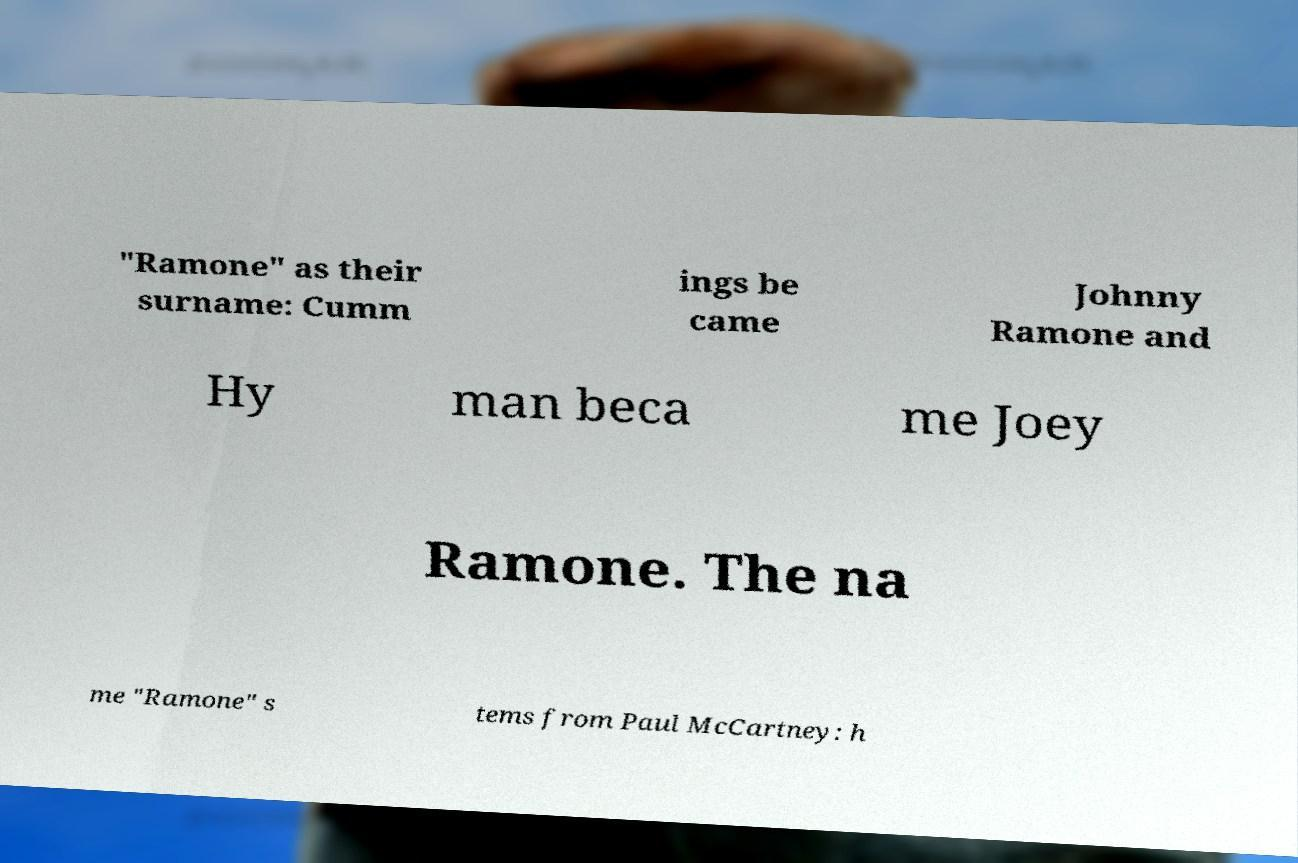There's text embedded in this image that I need extracted. Can you transcribe it verbatim? "Ramone" as their surname: Cumm ings be came Johnny Ramone and Hy man beca me Joey Ramone. The na me "Ramone" s tems from Paul McCartney: h 